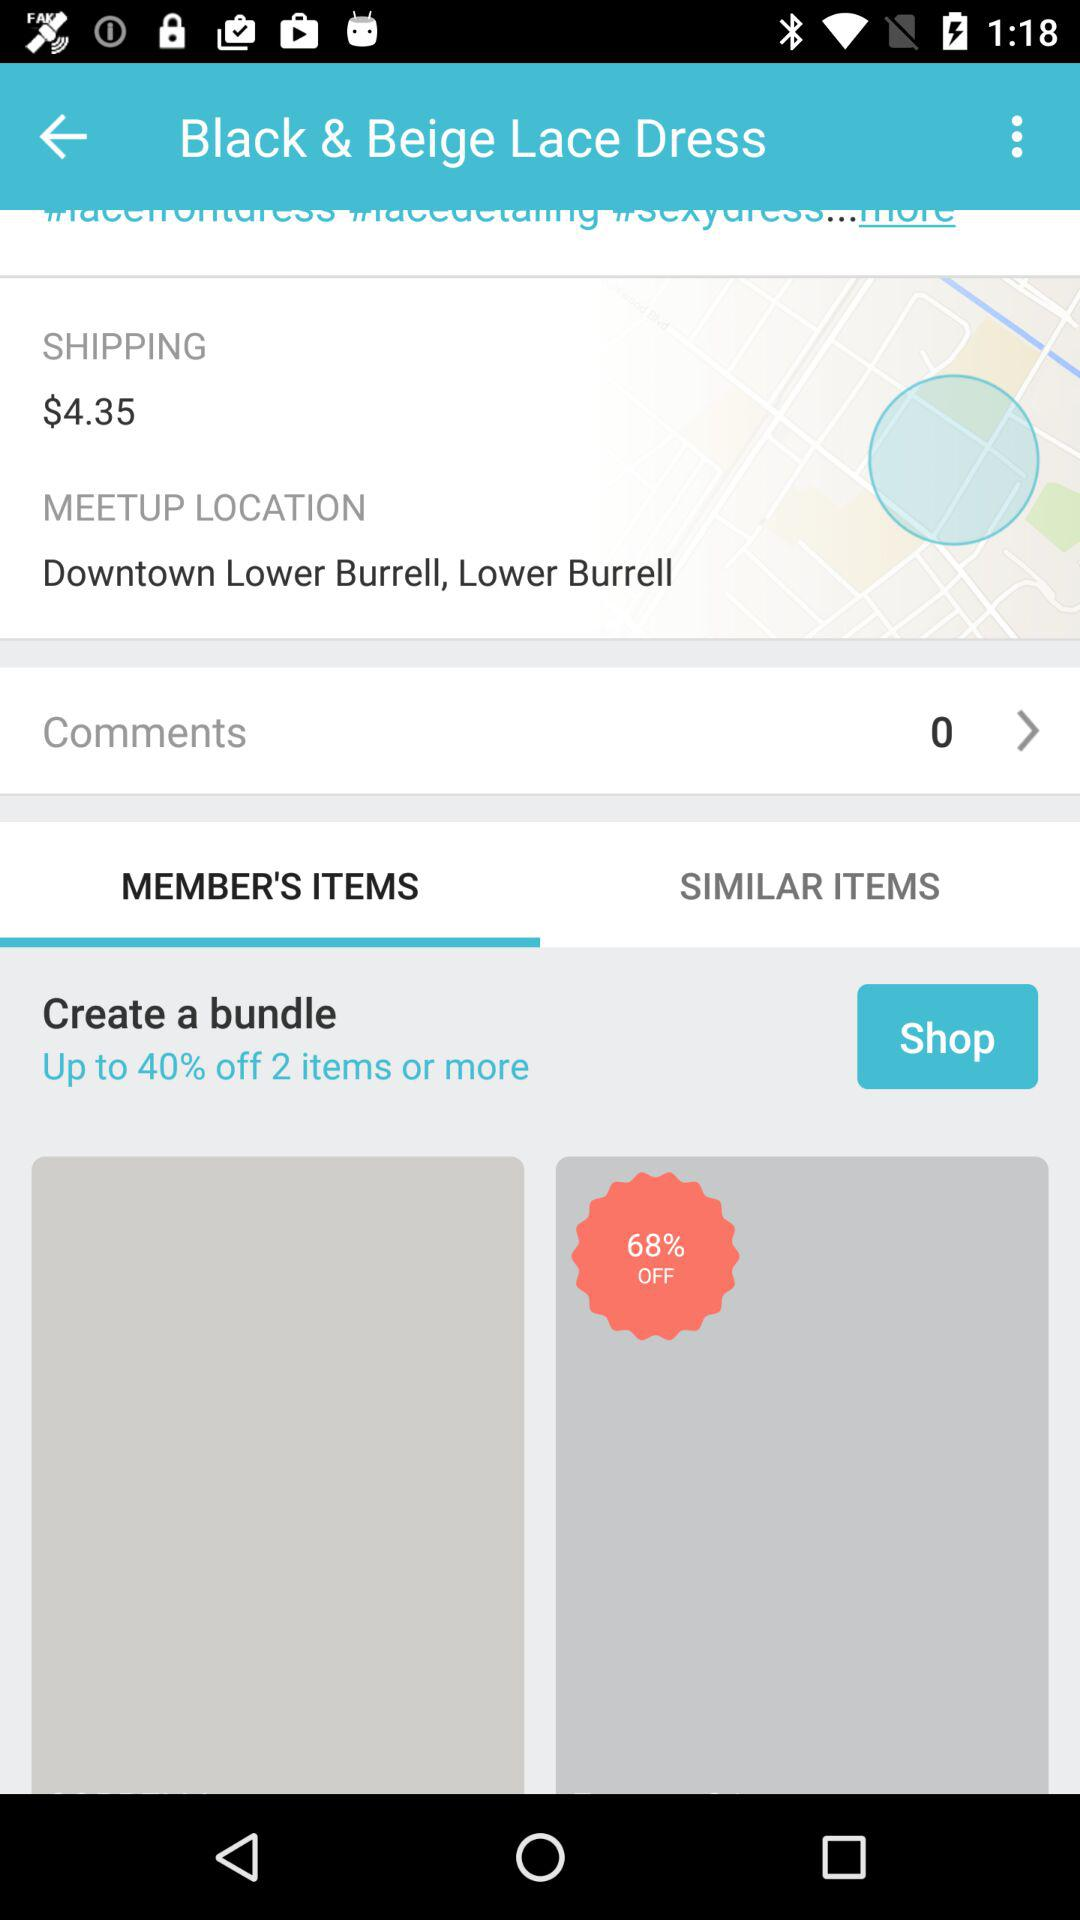What is the meetup location? The meetup location is Downtown Lower Burrell, Lower Burrell. 